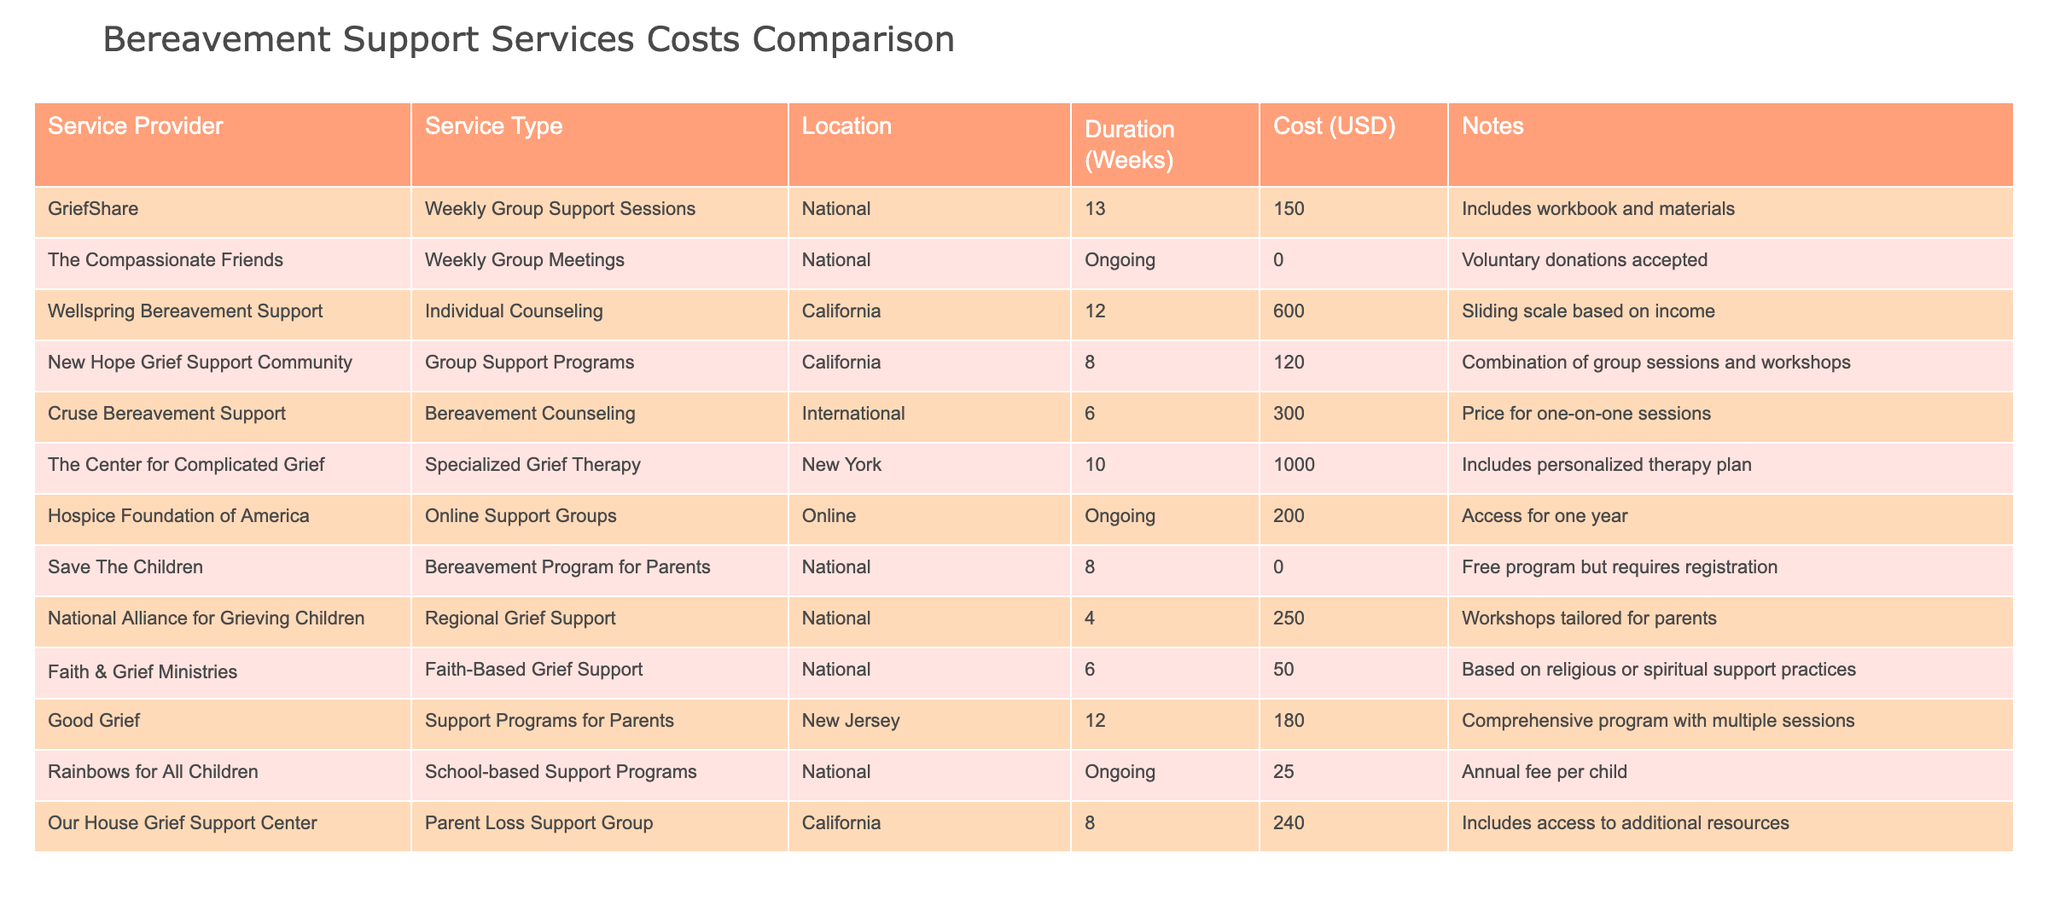What is the cost of individual counseling provided by Wellspring Bereavement Support? By looking at the table, I can find the row for Wellspring Bereavement Support under the "Service Provider" column. The "Cost (USD)" column in that row indicates a cost of 600.
Answer: 600 Which service offers support for free? The table lists several programs, but the row for Save The Children indicates a cost of 0, meaning it's a free program that requires registration.
Answer: Yes What is the average cost of the services offered in California? I find the costs for services in California: Wellspring Bereavement Support is 600, New Hope Grief Support Community is 120, and Our House Grief Support Center is 240. Summing these yields 600 + 120 + 240 = 960. There are 3 services, so the average cost is 960 / 3 = 320.
Answer: 320 Do any national programs have associated costs under 200? By examining the costs in the "Cost (USD)" column for national programs, I see that Faith & Grief Ministries costs 50 and New Hope Grief Support Community costs 120. Therefore, both of these national programs have costs under 200.
Answer: Yes Which service type has the highest cost, and what is that cost? Looking across all service types in the "Service Type" column, I see that the specialized grief therapy from The Center for Complicated Grief is listed at 1000 in the "Cost (USD)" column, which is the highest among all services.
Answer: Specialized Grief Therapy, 1000 What is the total cost of all services offered in the national category? I will calculate the total cost of national services by summing the relevant costs: GriefShare is 150, The Compassionate Friends is 0, New Hope Grief Support Community is 120, and Faith & Grief Ministries is 50. The total cost is 150 + 0 + 120 + 50 = 320.
Answer: 320 Is there a program specifically designed for bereaved parents? Examining the table, I find that Save The Children offers a Bereavement Program for Parents, as indicated in the "Service Type" column. Thus, there is a program specifically designed for bereaved parents.
Answer: Yes What is the difference in cost between the most expensive service and the least expensive service? The most expensive service is The Center for Complicated Grief at 1000, while the least expensive service is The Compassionate Friends at 0. The difference is 1000 - 0 = 1000.
Answer: 1000 